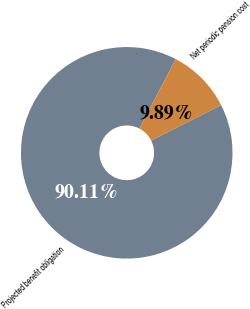<chart> <loc_0><loc_0><loc_500><loc_500><pie_chart><fcel>Projected benefit obligation<fcel>Net periodic pension cost<nl><fcel>90.11%<fcel>9.89%<nl></chart> 